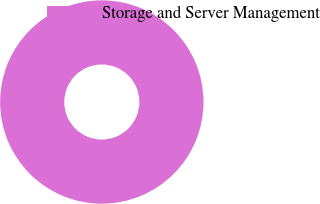<chart> <loc_0><loc_0><loc_500><loc_500><pie_chart><fcel>Storage and Server Management<nl><fcel>100.0%<nl></chart> 